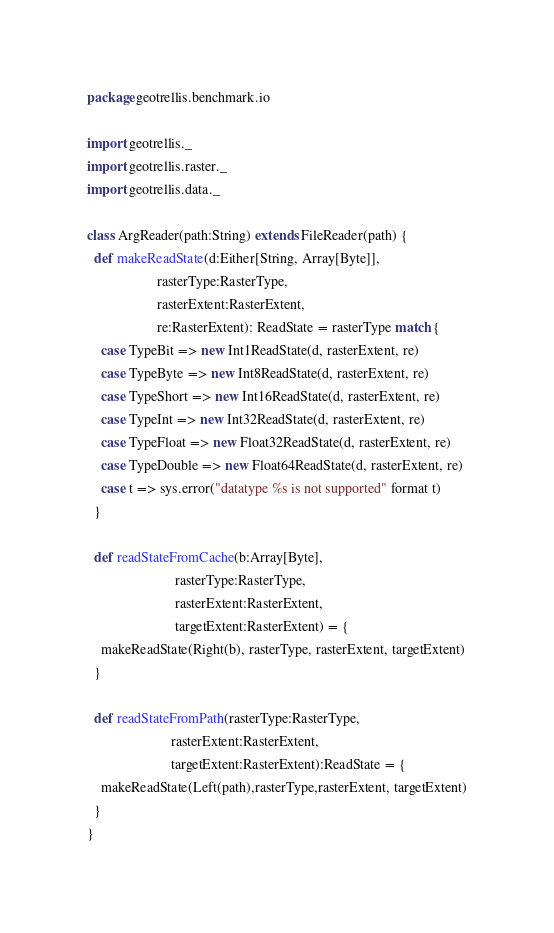<code> <loc_0><loc_0><loc_500><loc_500><_Scala_>package geotrellis.benchmark.io

import geotrellis._
import geotrellis.raster._
import geotrellis.data._

class ArgReader(path:String) extends FileReader(path) {
  def makeReadState(d:Either[String, Array[Byte]],
                    rasterType:RasterType,
                    rasterExtent:RasterExtent,
                    re:RasterExtent): ReadState = rasterType match {
    case TypeBit => new Int1ReadState(d, rasterExtent, re)
    case TypeByte => new Int8ReadState(d, rasterExtent, re)
    case TypeShort => new Int16ReadState(d, rasterExtent, re)
    case TypeInt => new Int32ReadState(d, rasterExtent, re)
    case TypeFloat => new Float32ReadState(d, rasterExtent, re)
    case TypeDouble => new Float64ReadState(d, rasterExtent, re)
    case t => sys.error("datatype %s is not supported" format t)
  }

  def readStateFromCache(b:Array[Byte], 
                         rasterType:RasterType, 
                         rasterExtent:RasterExtent, 
                         targetExtent:RasterExtent) = {
    makeReadState(Right(b), rasterType, rasterExtent, targetExtent)
  }

  def readStateFromPath(rasterType:RasterType, 
                        rasterExtent:RasterExtent,
                        targetExtent:RasterExtent):ReadState = {
    makeReadState(Left(path),rasterType,rasterExtent, targetExtent)
  }
}

</code> 